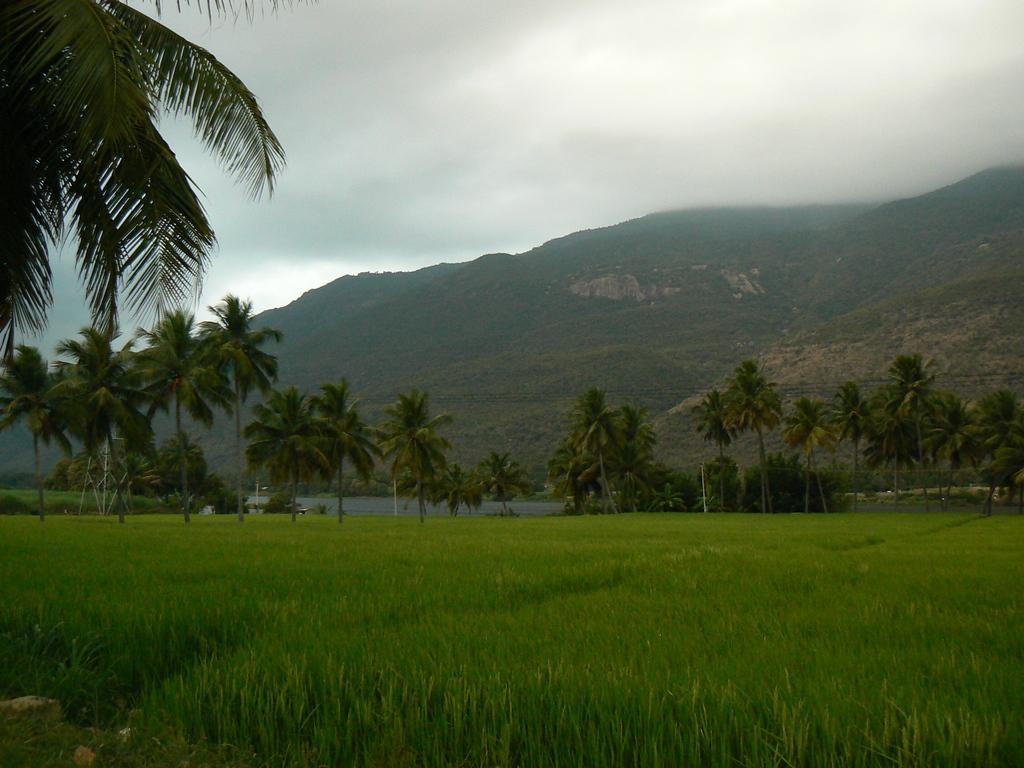What type of landscape is depicted in the image? The image features hills. What other natural elements can be seen in the image? There are trees and grass in the image. What is visible at the top of the image? The sky is visible at the top of the image. What type of string is being used to hold the trees together in the image? There is no string present in the image; the trees are not held together. 